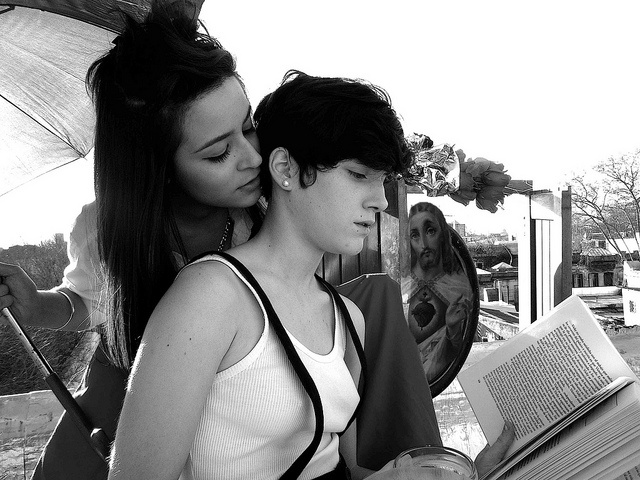Describe the objects in this image and their specific colors. I can see people in black, darkgray, dimgray, and lightgray tones, people in black, gray, darkgray, and white tones, book in black, darkgray, gray, and gainsboro tones, umbrella in black, lightgray, darkgray, and gray tones, and cup in black, gray, darkgray, and lightgray tones in this image. 